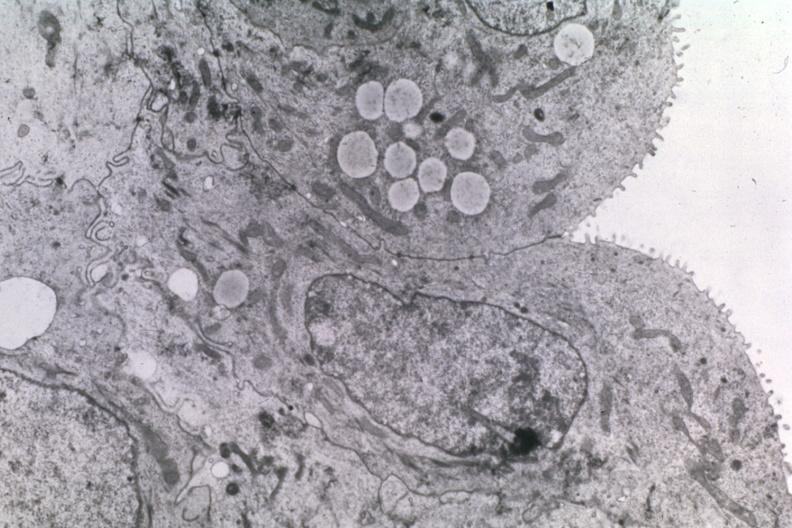s immunostain for growth hormone present?
Answer the question using a single word or phrase. No 